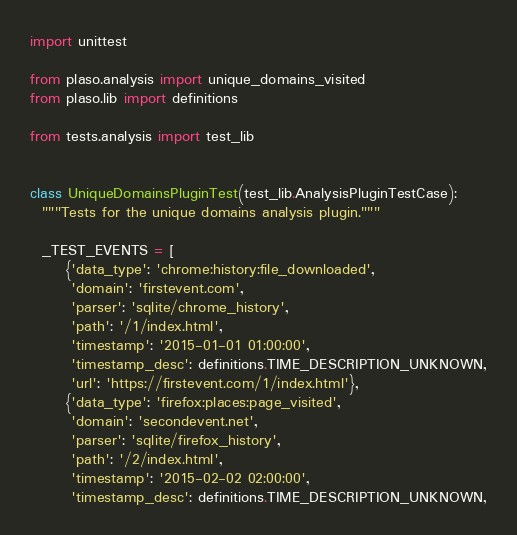<code> <loc_0><loc_0><loc_500><loc_500><_Python_>import unittest

from plaso.analysis import unique_domains_visited
from plaso.lib import definitions

from tests.analysis import test_lib


class UniqueDomainsPluginTest(test_lib.AnalysisPluginTestCase):
  """Tests for the unique domains analysis plugin."""

  _TEST_EVENTS = [
      {'data_type': 'chrome:history:file_downloaded',
       'domain': 'firstevent.com',
       'parser': 'sqlite/chrome_history',
       'path': '/1/index.html',
       'timestamp': '2015-01-01 01:00:00',
       'timestamp_desc': definitions.TIME_DESCRIPTION_UNKNOWN,
       'url': 'https://firstevent.com/1/index.html'},
      {'data_type': 'firefox:places:page_visited',
       'domain': 'secondevent.net',
       'parser': 'sqlite/firefox_history',
       'path': '/2/index.html',
       'timestamp': '2015-02-02 02:00:00',
       'timestamp_desc': definitions.TIME_DESCRIPTION_UNKNOWN,</code> 